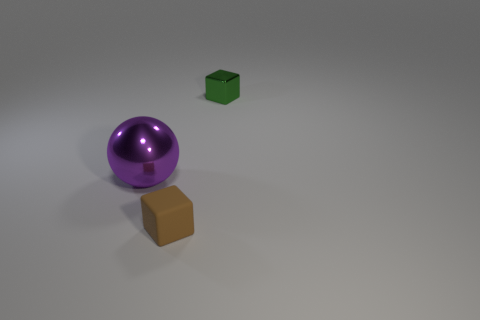Add 1 large green cylinders. How many objects exist? 4 Subtract all balls. How many objects are left? 2 Add 1 tiny gray matte spheres. How many tiny gray matte spheres exist? 1 Subtract 0 red blocks. How many objects are left? 3 Subtract all green things. Subtract all large things. How many objects are left? 1 Add 3 small rubber blocks. How many small rubber blocks are left? 4 